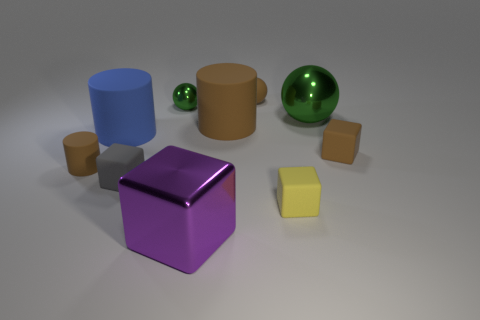What is the material of the large object that is right of the tiny yellow matte object?
Give a very brief answer. Metal. What is the shape of the tiny shiny thing that is the same color as the large sphere?
Your answer should be very brief. Sphere. Is there a tiny gray block made of the same material as the yellow thing?
Offer a very short reply. Yes. What is the size of the purple metal block?
Ensure brevity in your answer.  Large. How many cyan things are large matte cylinders or matte objects?
Offer a terse response. 0. What number of blue objects have the same shape as the large brown thing?
Give a very brief answer. 1. How many red rubber balls have the same size as the blue cylinder?
Offer a terse response. 0. What material is the other large thing that is the same shape as the blue thing?
Your answer should be very brief. Rubber. The large shiny object that is on the right side of the large cube is what color?
Your answer should be compact. Green. Is the number of brown rubber blocks in front of the small matte cylinder greater than the number of tiny cyan metallic cylinders?
Provide a short and direct response. No. 